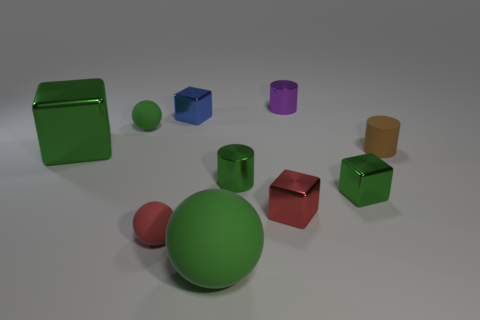What size is the other cube that is the same color as the large cube?
Offer a terse response. Small. There is a green matte sphere to the left of the small rubber sphere on the right side of the green matte ball behind the tiny red ball; how big is it?
Your answer should be very brief. Small. What number of gray balls have the same material as the large green ball?
Make the answer very short. 0. What number of blue metal objects have the same size as the red shiny object?
Provide a succinct answer. 1. What material is the small cylinder behind the green shiny thing behind the small green metal thing that is on the left side of the purple shiny thing?
Provide a succinct answer. Metal. What number of things are either small green metal cylinders or red matte spheres?
Your answer should be very brief. 2. Is there anything else that is the same material as the small brown cylinder?
Your answer should be very brief. Yes. What shape is the purple shiny object?
Ensure brevity in your answer.  Cylinder. What is the shape of the green matte object that is to the right of the small rubber thing that is behind the big shiny cube?
Your response must be concise. Sphere. Does the tiny cylinder that is behind the blue shiny block have the same material as the large cube?
Give a very brief answer. Yes. 